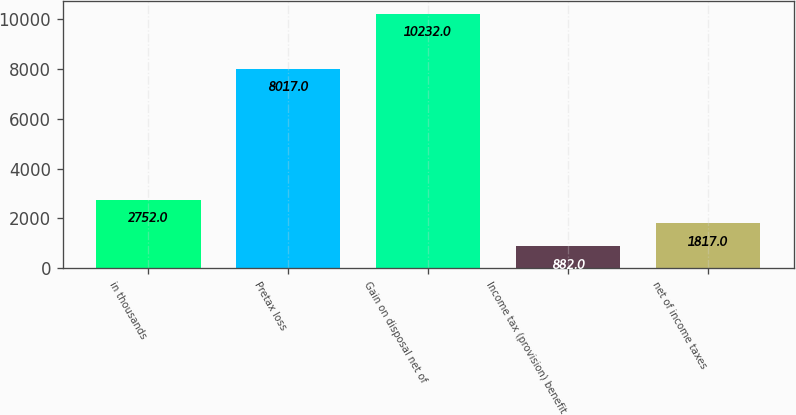Convert chart to OTSL. <chart><loc_0><loc_0><loc_500><loc_500><bar_chart><fcel>in thousands<fcel>Pretax loss<fcel>Gain on disposal net of<fcel>Income tax (provision) benefit<fcel>net of income taxes<nl><fcel>2752<fcel>8017<fcel>10232<fcel>882<fcel>1817<nl></chart> 